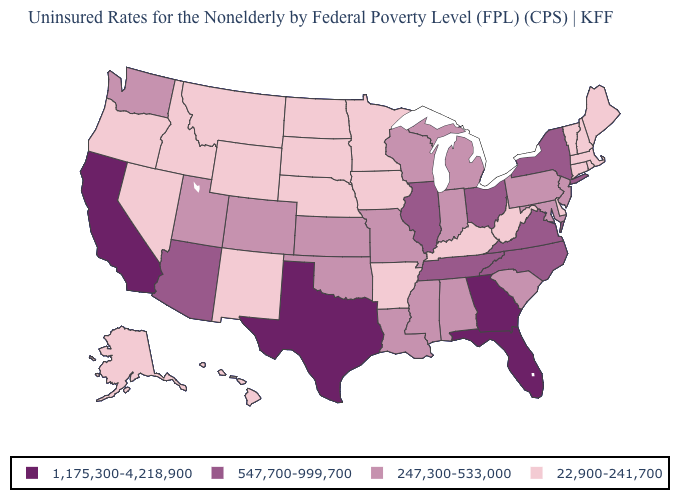Does Pennsylvania have the lowest value in the USA?
Keep it brief. No. What is the value of Connecticut?
Quick response, please. 22,900-241,700. What is the value of North Dakota?
Short answer required. 22,900-241,700. What is the value of Pennsylvania?
Quick response, please. 247,300-533,000. Name the states that have a value in the range 547,700-999,700?
Short answer required. Arizona, Illinois, New York, North Carolina, Ohio, Tennessee, Virginia. What is the value of Rhode Island?
Give a very brief answer. 22,900-241,700. Name the states that have a value in the range 22,900-241,700?
Concise answer only. Alaska, Arkansas, Connecticut, Delaware, Hawaii, Idaho, Iowa, Kentucky, Maine, Massachusetts, Minnesota, Montana, Nebraska, Nevada, New Hampshire, New Mexico, North Dakota, Oregon, Rhode Island, South Dakota, Vermont, West Virginia, Wyoming. What is the lowest value in the USA?
Answer briefly. 22,900-241,700. Which states hav the highest value in the West?
Short answer required. California. Does the first symbol in the legend represent the smallest category?
Be succinct. No. Does Virginia have the lowest value in the USA?
Write a very short answer. No. Which states have the lowest value in the USA?
Answer briefly. Alaska, Arkansas, Connecticut, Delaware, Hawaii, Idaho, Iowa, Kentucky, Maine, Massachusetts, Minnesota, Montana, Nebraska, Nevada, New Hampshire, New Mexico, North Dakota, Oregon, Rhode Island, South Dakota, Vermont, West Virginia, Wyoming. Name the states that have a value in the range 22,900-241,700?
Give a very brief answer. Alaska, Arkansas, Connecticut, Delaware, Hawaii, Idaho, Iowa, Kentucky, Maine, Massachusetts, Minnesota, Montana, Nebraska, Nevada, New Hampshire, New Mexico, North Dakota, Oregon, Rhode Island, South Dakota, Vermont, West Virginia, Wyoming. Name the states that have a value in the range 22,900-241,700?
Answer briefly. Alaska, Arkansas, Connecticut, Delaware, Hawaii, Idaho, Iowa, Kentucky, Maine, Massachusetts, Minnesota, Montana, Nebraska, Nevada, New Hampshire, New Mexico, North Dakota, Oregon, Rhode Island, South Dakota, Vermont, West Virginia, Wyoming. Name the states that have a value in the range 1,175,300-4,218,900?
Short answer required. California, Florida, Georgia, Texas. 